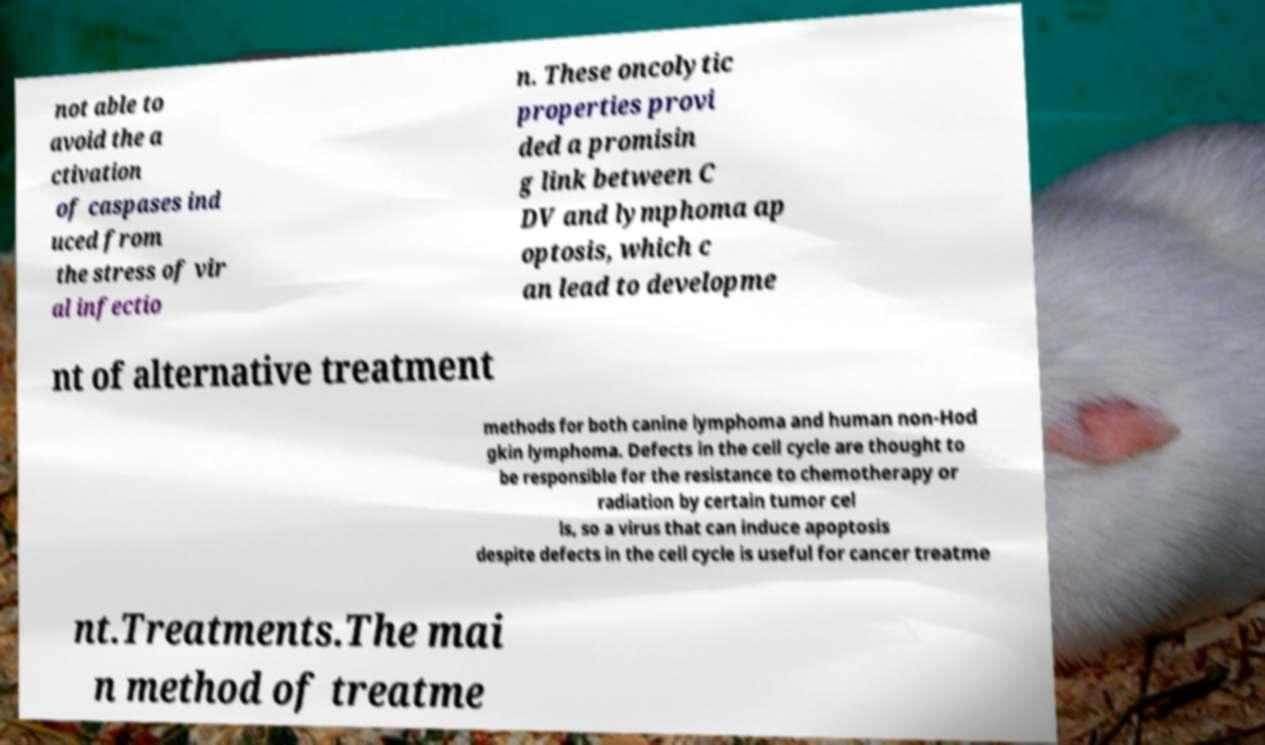Please read and relay the text visible in this image. What does it say? not able to avoid the a ctivation of caspases ind uced from the stress of vir al infectio n. These oncolytic properties provi ded a promisin g link between C DV and lymphoma ap optosis, which c an lead to developme nt of alternative treatment methods for both canine lymphoma and human non-Hod gkin lymphoma. Defects in the cell cycle are thought to be responsible for the resistance to chemotherapy or radiation by certain tumor cel ls, so a virus that can induce apoptosis despite defects in the cell cycle is useful for cancer treatme nt.Treatments.The mai n method of treatme 